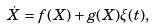Convert formula to latex. <formula><loc_0><loc_0><loc_500><loc_500>\dot { X } = f ( X ) + g ( X ) \xi ( t ) ,</formula> 